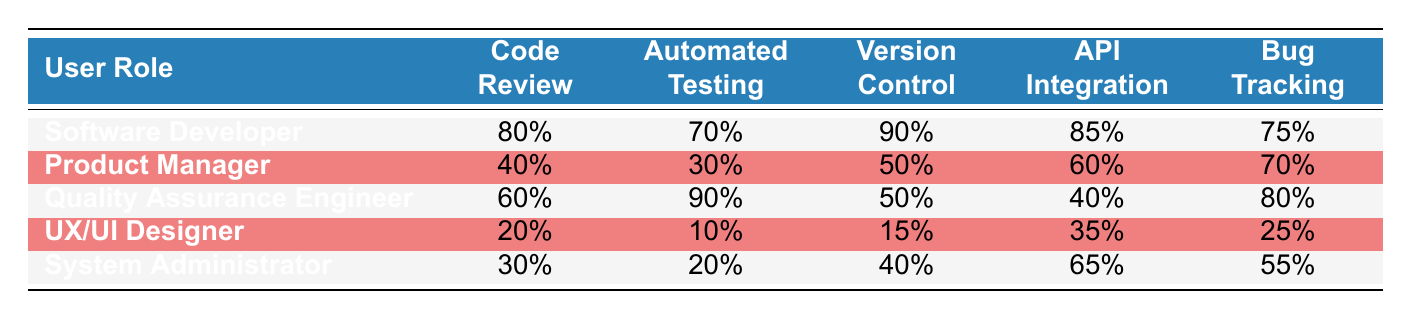What is the highest percentage of feature usage for a Software Developer? According to the table, the feature usage percentages for Software Developers are: Code Review (80%), Automated Testing (70%), Version Control (90%), API Integration (85%), and Bug Tracking (75%). The highest percentage among these is 90% for Version Control.
Answer: 90% Which user role has the lowest percentage of Automated Testing usage? The feature usage percentages for Automated Testing are: Software Developer (70%), Product Manager (30%), Quality Assurance Engineer (90%), UX/UI Designer (10%), and System Administrator (20%). The lowest percentage is 10%, which belongs to the UX/UI Designer.
Answer: UX/UI Designer True or False: Quality Assurance Engineers have a higher percentage of Bug Tracking usage than Software Developers. The Bug Tracking percentages are: Software Developer (75%) and Quality Assurance Engineer (80%). Comparing these two values, 80% (QA Engineer) is greater than 75% (Software Developer), making the statement true.
Answer: True What is the average percentage of Code Review usage across all user roles? The Code Review percentages are: 80%, 40%, 60%, 20%, and 30%. The sum is 80 + 40 + 60 + 20 + 30 = 230. There are 5 user roles, so the average is 230 / 5 = 46.
Answer: 46% Which feature has the greatest disparity in usage between the highest and lowest user role? The highest and lowest percentages for each feature are: Code Review (80% and 20%), Automated Testing (90% and 10%), Version Control (90% and 15%), API Integration (85% and 35%), and Bug Tracking (80% and 25%). The disparities are: Code Review (60%), Automated Testing (80%), Version Control (75%), API Integration (50%), and Bug Tracking (55%). The greatest disparity is 80% for Automated Testing.
Answer: Automated Testing 